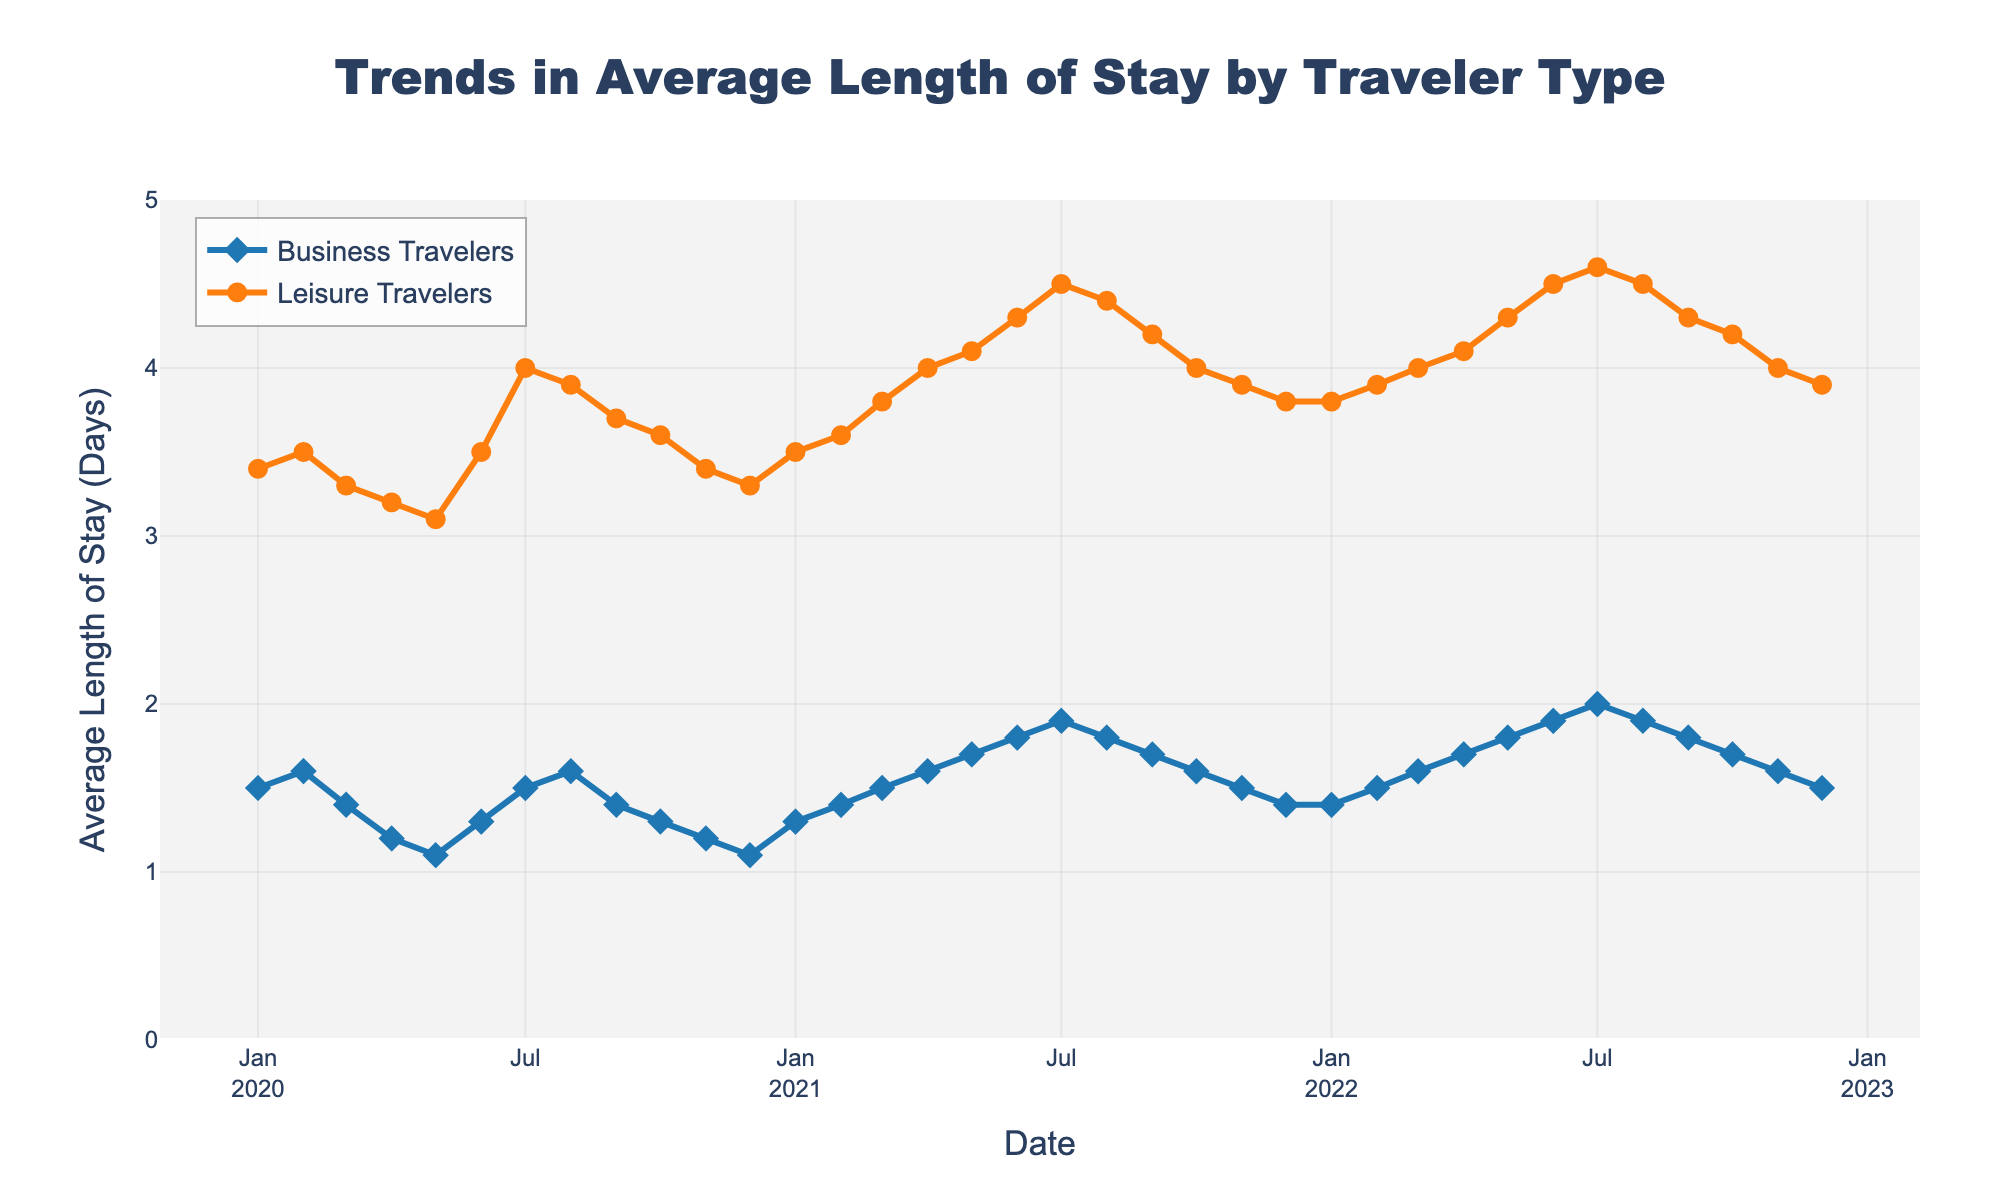what is the average length of stay in June 2020 for leisure travelers? To find this, locate the month "2020-06" on the x-axis and observe the value for "Leisure Travelers (Avg Length of Stay)" on the y-axis. The length of stay is 3.5.
Answer: 3.5 how did the average length of stay change for business travelers from January 2020 to January 2021? Locate the points for "Business Travelers" at "2020-01" and "2021-01". In January 2020, the length of stay was 1.5 days; by January 2021, it was 1.3 days. The change is 1.3 - 1.5 = -0.2 days.
Answer: -0.2 days which month saw the highest average length of stay for leisure travelers? Look across the plot for the peak in the "Leisure Travelers" line. The maximum value of 4.6 days occurs in July 2022.
Answer: July 2022 during which months did business travelers have an average length of stay greater than 1.8 days? Identify points in the business travelers' line above the 1.8-day mark. These points are in July 2022 only.
Answer: July 2022 what is the difference between the length of stay for business travelers and leisure travelers in August 2022? For August 2022, the length of stay for business travelers is 1.9 days and for leisure travelers is 4.5 days. The difference is 4.5 - 1.9 = 2.6 days.
Answer: 2.6 days how does the trend in length of stay compare between business and leisure travelers from January 2021 to December 2022? Observing the plot from 2021-01 to 2022-12, the trend for both types of travelers generally shows an increase. Business travelers’ stays rise from 1.3 to 1.5 days, while leisure travelers’ stays rise from 3.5 to 3.9 days.
Answer: Both trends increase what pattern do you observe in the average length of stay for business travelers from January 2021 to August 2022? From January 2021 to August 2022, the average length of stay for business travelers generally increases, peaking at 2.0 days in July 2022 before slightly decreasing.
Answer: Increasing, then slightly decreasing how much did the average length of stay for leisure travelers increase from April 2020 to April 2021? The value in April 2020 was 3.2 days, and in April 2021, it was 4.0 days. The increase is 4.0 - 3.2 = 0.8 days.
Answer: 0.8 days 